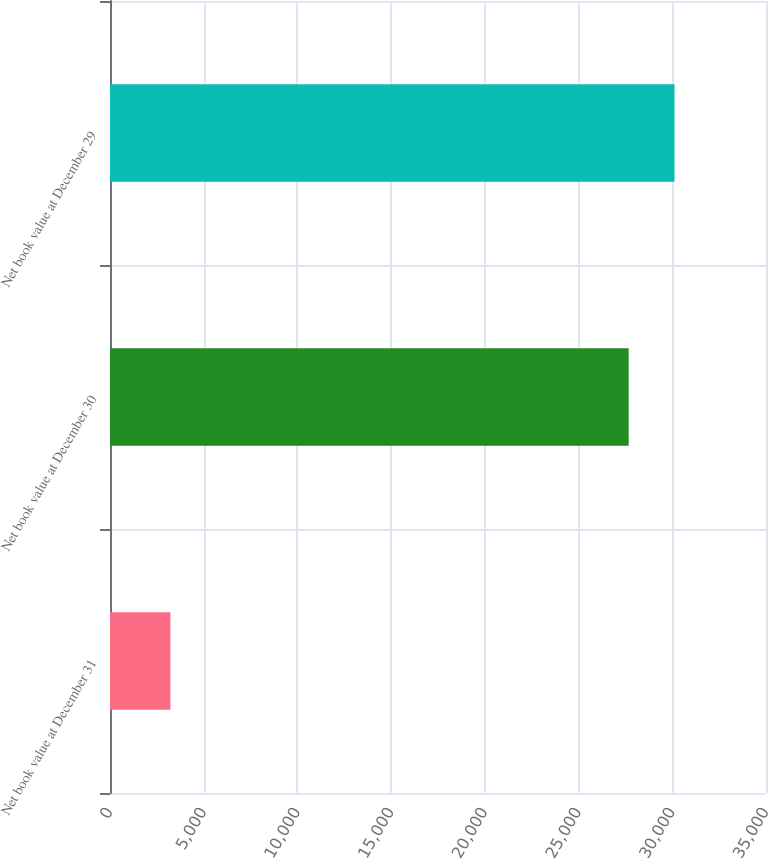Convert chart to OTSL. <chart><loc_0><loc_0><loc_500><loc_500><bar_chart><fcel>Net book value at December 31<fcel>Net book value at December 30<fcel>Net book value at December 29<nl><fcel>3224<fcel>27673<fcel>30117.9<nl></chart> 